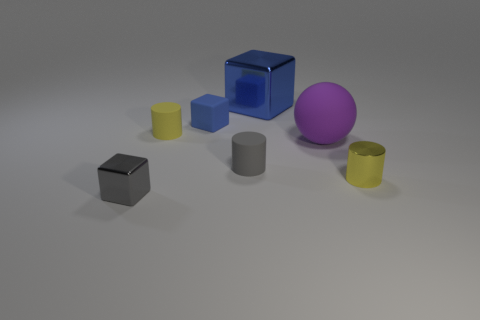Does the blue cube that is left of the tiny gray cylinder have the same size as the rubber object that is on the right side of the blue metal block?
Keep it short and to the point. No. What is the size of the shiny object left of the yellow rubber thing?
Your answer should be very brief. Small. There is a small cube that is the same color as the big metal cube; what is its material?
Offer a very short reply. Rubber. Is the gray rubber object the same size as the blue shiny cube?
Your response must be concise. No. There is a cylinder that is both in front of the big purple matte thing and behind the small shiny cylinder; what size is it?
Provide a short and direct response. Small. Is there a big blue metal thing that has the same shape as the tiny yellow matte thing?
Your answer should be compact. No. How many gray matte objects are there?
Ensure brevity in your answer.  1. Does the blue cube that is on the left side of the gray cylinder have the same material as the gray cube?
Your response must be concise. No. Are there any blue blocks that have the same size as the yellow matte cylinder?
Provide a succinct answer. Yes. There is a tiny blue thing; is its shape the same as the small metallic thing in front of the yellow shiny object?
Keep it short and to the point. Yes. 